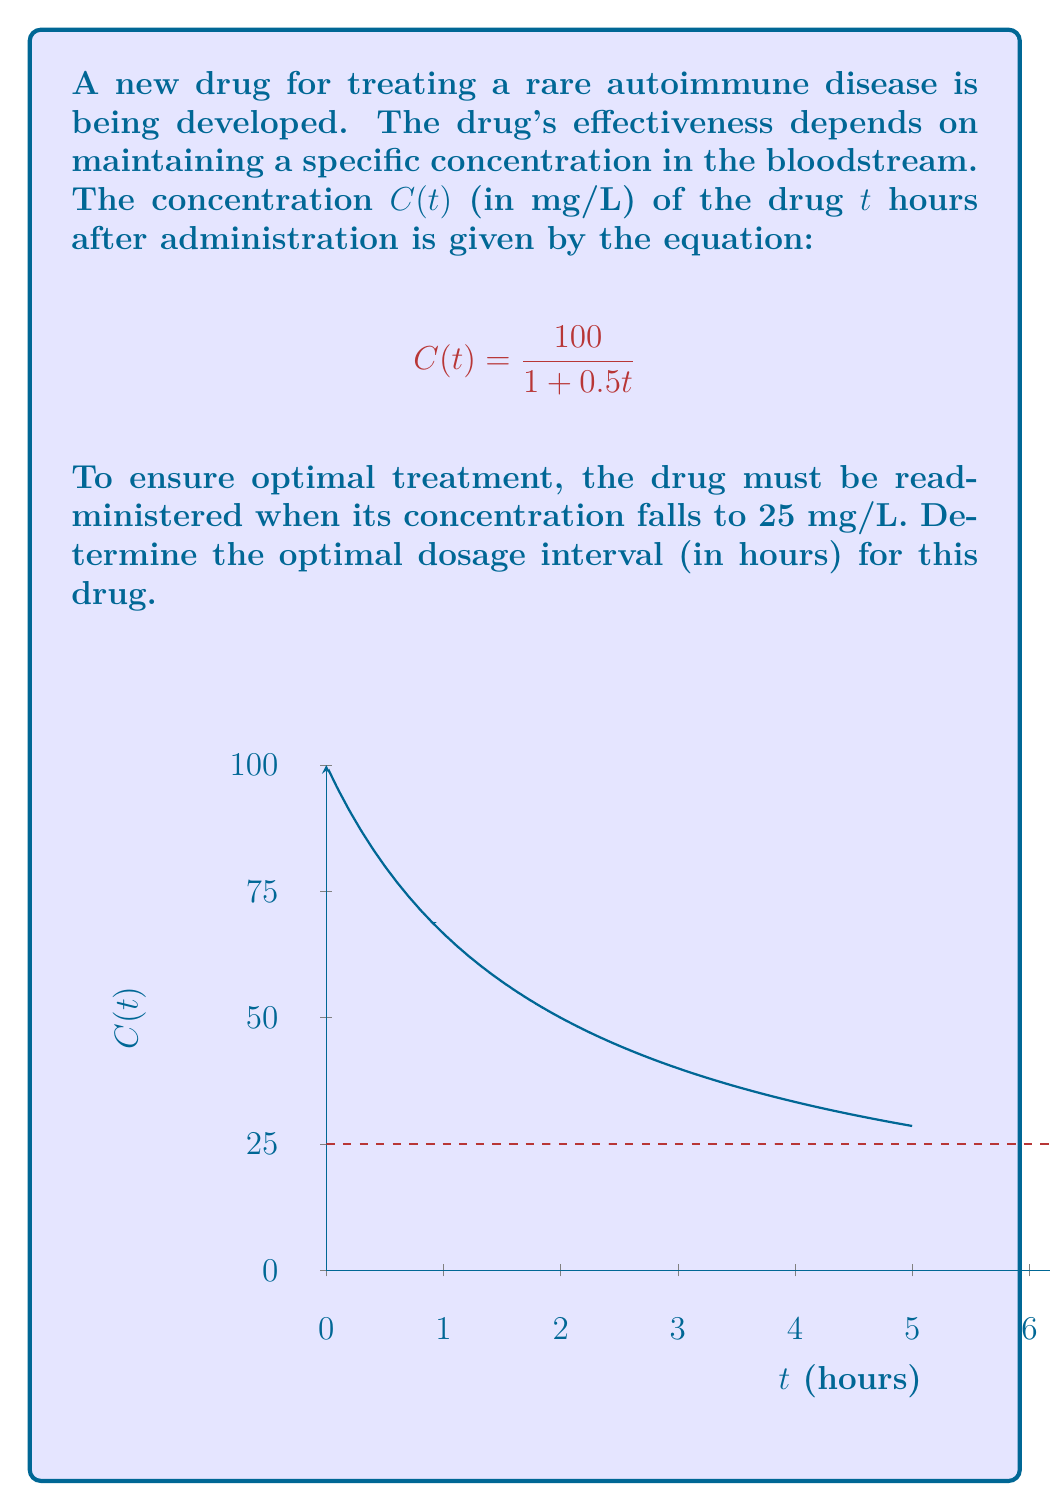Solve this math problem. To find the optimal dosage interval, we need to solve the equation:

$$\frac{100}{1 + 0.5t} = 25$$

Step 1: Multiply both sides by $(1 + 0.5t)$:
$100 = 25(1 + 0.5t)$

Step 2: Distribute on the right side:
$100 = 25 + 12.5t$

Step 3: Subtract 25 from both sides:
$75 = 12.5t$

Step 4: Divide both sides by 12.5:
$t = 6$

Therefore, the drug concentration will reach 25 mg/L after 6 hours.

The optimal dosage interval is 6 hours, ensuring that the drug is readministered when its concentration reaches the specified threshold of 25 mg/L.
Answer: 6 hours 